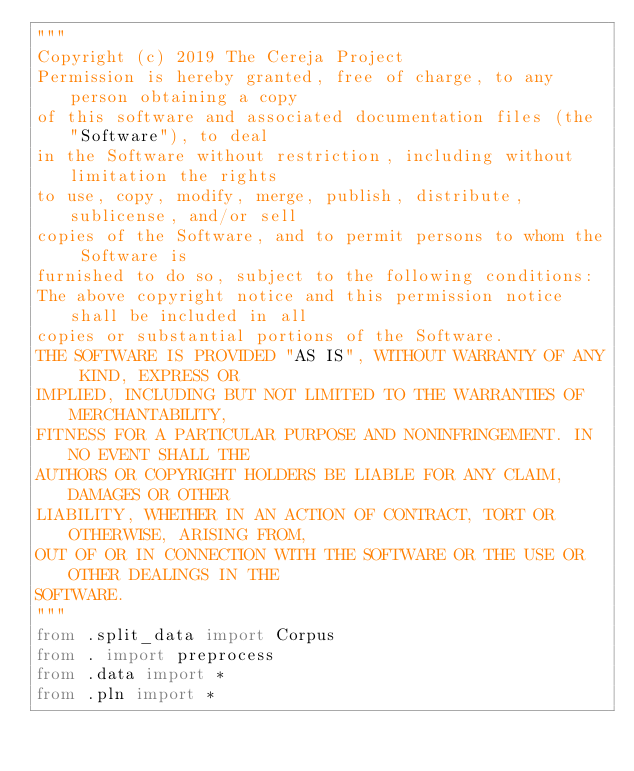Convert code to text. <code><loc_0><loc_0><loc_500><loc_500><_Python_>"""
Copyright (c) 2019 The Cereja Project
Permission is hereby granted, free of charge, to any person obtaining a copy
of this software and associated documentation files (the "Software"), to deal
in the Software without restriction, including without limitation the rights
to use, copy, modify, merge, publish, distribute, sublicense, and/or sell
copies of the Software, and to permit persons to whom the Software is
furnished to do so, subject to the following conditions:
The above copyright notice and this permission notice shall be included in all
copies or substantial portions of the Software.
THE SOFTWARE IS PROVIDED "AS IS", WITHOUT WARRANTY OF ANY KIND, EXPRESS OR
IMPLIED, INCLUDING BUT NOT LIMITED TO THE WARRANTIES OF MERCHANTABILITY,
FITNESS FOR A PARTICULAR PURPOSE AND NONINFRINGEMENT. IN NO EVENT SHALL THE
AUTHORS OR COPYRIGHT HOLDERS BE LIABLE FOR ANY CLAIM, DAMAGES OR OTHER
LIABILITY, WHETHER IN AN ACTION OF CONTRACT, TORT OR OTHERWISE, ARISING FROM,
OUT OF OR IN CONNECTION WITH THE SOFTWARE OR THE USE OR OTHER DEALINGS IN THE
SOFTWARE.
"""
from .split_data import Corpus
from . import preprocess
from .data import *
from .pln import *
</code> 